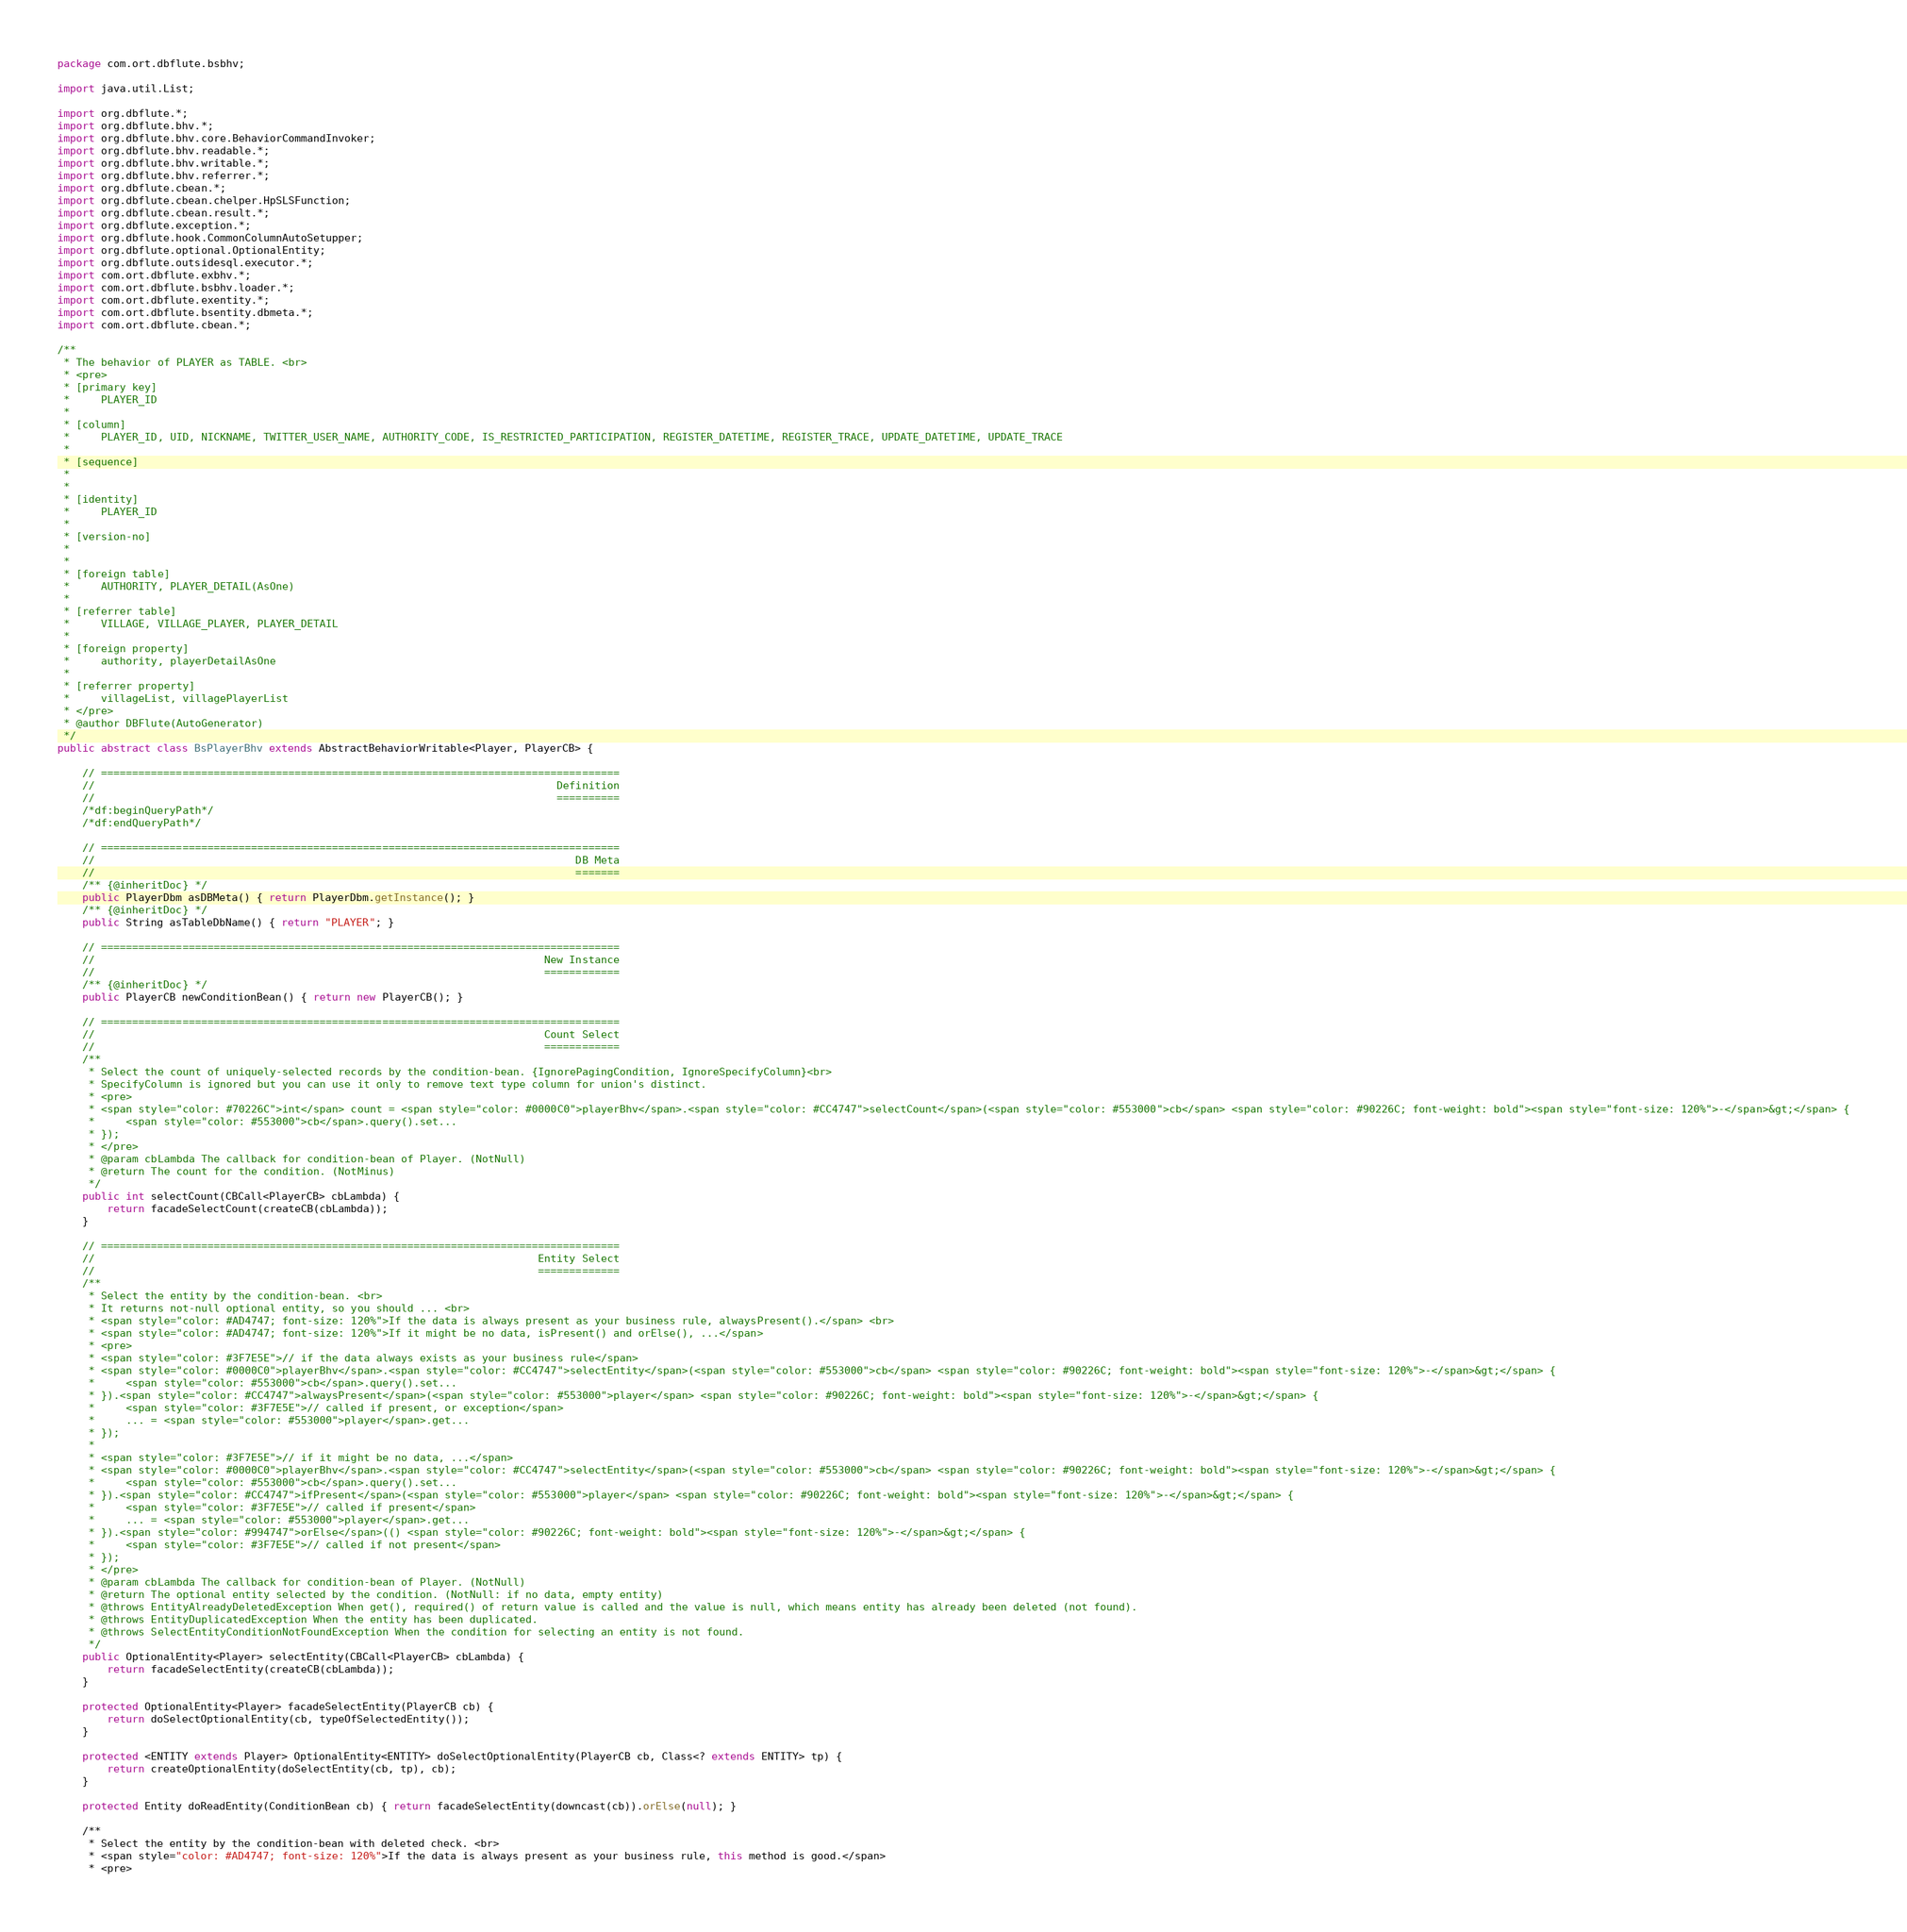<code> <loc_0><loc_0><loc_500><loc_500><_Java_>package com.ort.dbflute.bsbhv;

import java.util.List;

import org.dbflute.*;
import org.dbflute.bhv.*;
import org.dbflute.bhv.core.BehaviorCommandInvoker;
import org.dbflute.bhv.readable.*;
import org.dbflute.bhv.writable.*;
import org.dbflute.bhv.referrer.*;
import org.dbflute.cbean.*;
import org.dbflute.cbean.chelper.HpSLSFunction;
import org.dbflute.cbean.result.*;
import org.dbflute.exception.*;
import org.dbflute.hook.CommonColumnAutoSetupper;
import org.dbflute.optional.OptionalEntity;
import org.dbflute.outsidesql.executor.*;
import com.ort.dbflute.exbhv.*;
import com.ort.dbflute.bsbhv.loader.*;
import com.ort.dbflute.exentity.*;
import com.ort.dbflute.bsentity.dbmeta.*;
import com.ort.dbflute.cbean.*;

/**
 * The behavior of PLAYER as TABLE. <br>
 * <pre>
 * [primary key]
 *     PLAYER_ID
 *
 * [column]
 *     PLAYER_ID, UID, NICKNAME, TWITTER_USER_NAME, AUTHORITY_CODE, IS_RESTRICTED_PARTICIPATION, REGISTER_DATETIME, REGISTER_TRACE, UPDATE_DATETIME, UPDATE_TRACE
 *
 * [sequence]
 *     
 *
 * [identity]
 *     PLAYER_ID
 *
 * [version-no]
 *     
 *
 * [foreign table]
 *     AUTHORITY, PLAYER_DETAIL(AsOne)
 *
 * [referrer table]
 *     VILLAGE, VILLAGE_PLAYER, PLAYER_DETAIL
 *
 * [foreign property]
 *     authority, playerDetailAsOne
 *
 * [referrer property]
 *     villageList, villagePlayerList
 * </pre>
 * @author DBFlute(AutoGenerator)
 */
public abstract class BsPlayerBhv extends AbstractBehaviorWritable<Player, PlayerCB> {

    // ===================================================================================
    //                                                                          Definition
    //                                                                          ==========
    /*df:beginQueryPath*/
    /*df:endQueryPath*/

    // ===================================================================================
    //                                                                             DB Meta
    //                                                                             =======
    /** {@inheritDoc} */
    public PlayerDbm asDBMeta() { return PlayerDbm.getInstance(); }
    /** {@inheritDoc} */
    public String asTableDbName() { return "PLAYER"; }

    // ===================================================================================
    //                                                                        New Instance
    //                                                                        ============
    /** {@inheritDoc} */
    public PlayerCB newConditionBean() { return new PlayerCB(); }

    // ===================================================================================
    //                                                                        Count Select
    //                                                                        ============
    /**
     * Select the count of uniquely-selected records by the condition-bean. {IgnorePagingCondition, IgnoreSpecifyColumn}<br>
     * SpecifyColumn is ignored but you can use it only to remove text type column for union's distinct.
     * <pre>
     * <span style="color: #70226C">int</span> count = <span style="color: #0000C0">playerBhv</span>.<span style="color: #CC4747">selectCount</span>(<span style="color: #553000">cb</span> <span style="color: #90226C; font-weight: bold"><span style="font-size: 120%">-</span>&gt;</span> {
     *     <span style="color: #553000">cb</span>.query().set...
     * });
     * </pre>
     * @param cbLambda The callback for condition-bean of Player. (NotNull)
     * @return The count for the condition. (NotMinus)
     */
    public int selectCount(CBCall<PlayerCB> cbLambda) {
        return facadeSelectCount(createCB(cbLambda));
    }

    // ===================================================================================
    //                                                                       Entity Select
    //                                                                       =============
    /**
     * Select the entity by the condition-bean. <br>
     * It returns not-null optional entity, so you should ... <br>
     * <span style="color: #AD4747; font-size: 120%">If the data is always present as your business rule, alwaysPresent().</span> <br>
     * <span style="color: #AD4747; font-size: 120%">If it might be no data, isPresent() and orElse(), ...</span>
     * <pre>
     * <span style="color: #3F7E5E">// if the data always exists as your business rule</span>
     * <span style="color: #0000C0">playerBhv</span>.<span style="color: #CC4747">selectEntity</span>(<span style="color: #553000">cb</span> <span style="color: #90226C; font-weight: bold"><span style="font-size: 120%">-</span>&gt;</span> {
     *     <span style="color: #553000">cb</span>.query().set...
     * }).<span style="color: #CC4747">alwaysPresent</span>(<span style="color: #553000">player</span> <span style="color: #90226C; font-weight: bold"><span style="font-size: 120%">-</span>&gt;</span> {
     *     <span style="color: #3F7E5E">// called if present, or exception</span>
     *     ... = <span style="color: #553000">player</span>.get...
     * });
     *
     * <span style="color: #3F7E5E">// if it might be no data, ...</span>
     * <span style="color: #0000C0">playerBhv</span>.<span style="color: #CC4747">selectEntity</span>(<span style="color: #553000">cb</span> <span style="color: #90226C; font-weight: bold"><span style="font-size: 120%">-</span>&gt;</span> {
     *     <span style="color: #553000">cb</span>.query().set...
     * }).<span style="color: #CC4747">ifPresent</span>(<span style="color: #553000">player</span> <span style="color: #90226C; font-weight: bold"><span style="font-size: 120%">-</span>&gt;</span> {
     *     <span style="color: #3F7E5E">// called if present</span>
     *     ... = <span style="color: #553000">player</span>.get...
     * }).<span style="color: #994747">orElse</span>(() <span style="color: #90226C; font-weight: bold"><span style="font-size: 120%">-</span>&gt;</span> {
     *     <span style="color: #3F7E5E">// called if not present</span>
     * });
     * </pre>
     * @param cbLambda The callback for condition-bean of Player. (NotNull)
     * @return The optional entity selected by the condition. (NotNull: if no data, empty entity)
     * @throws EntityAlreadyDeletedException When get(), required() of return value is called and the value is null, which means entity has already been deleted (not found).
     * @throws EntityDuplicatedException When the entity has been duplicated.
     * @throws SelectEntityConditionNotFoundException When the condition for selecting an entity is not found.
     */
    public OptionalEntity<Player> selectEntity(CBCall<PlayerCB> cbLambda) {
        return facadeSelectEntity(createCB(cbLambda));
    }

    protected OptionalEntity<Player> facadeSelectEntity(PlayerCB cb) {
        return doSelectOptionalEntity(cb, typeOfSelectedEntity());
    }

    protected <ENTITY extends Player> OptionalEntity<ENTITY> doSelectOptionalEntity(PlayerCB cb, Class<? extends ENTITY> tp) {
        return createOptionalEntity(doSelectEntity(cb, tp), cb);
    }

    protected Entity doReadEntity(ConditionBean cb) { return facadeSelectEntity(downcast(cb)).orElse(null); }

    /**
     * Select the entity by the condition-bean with deleted check. <br>
     * <span style="color: #AD4747; font-size: 120%">If the data is always present as your business rule, this method is good.</span>
     * <pre></code> 